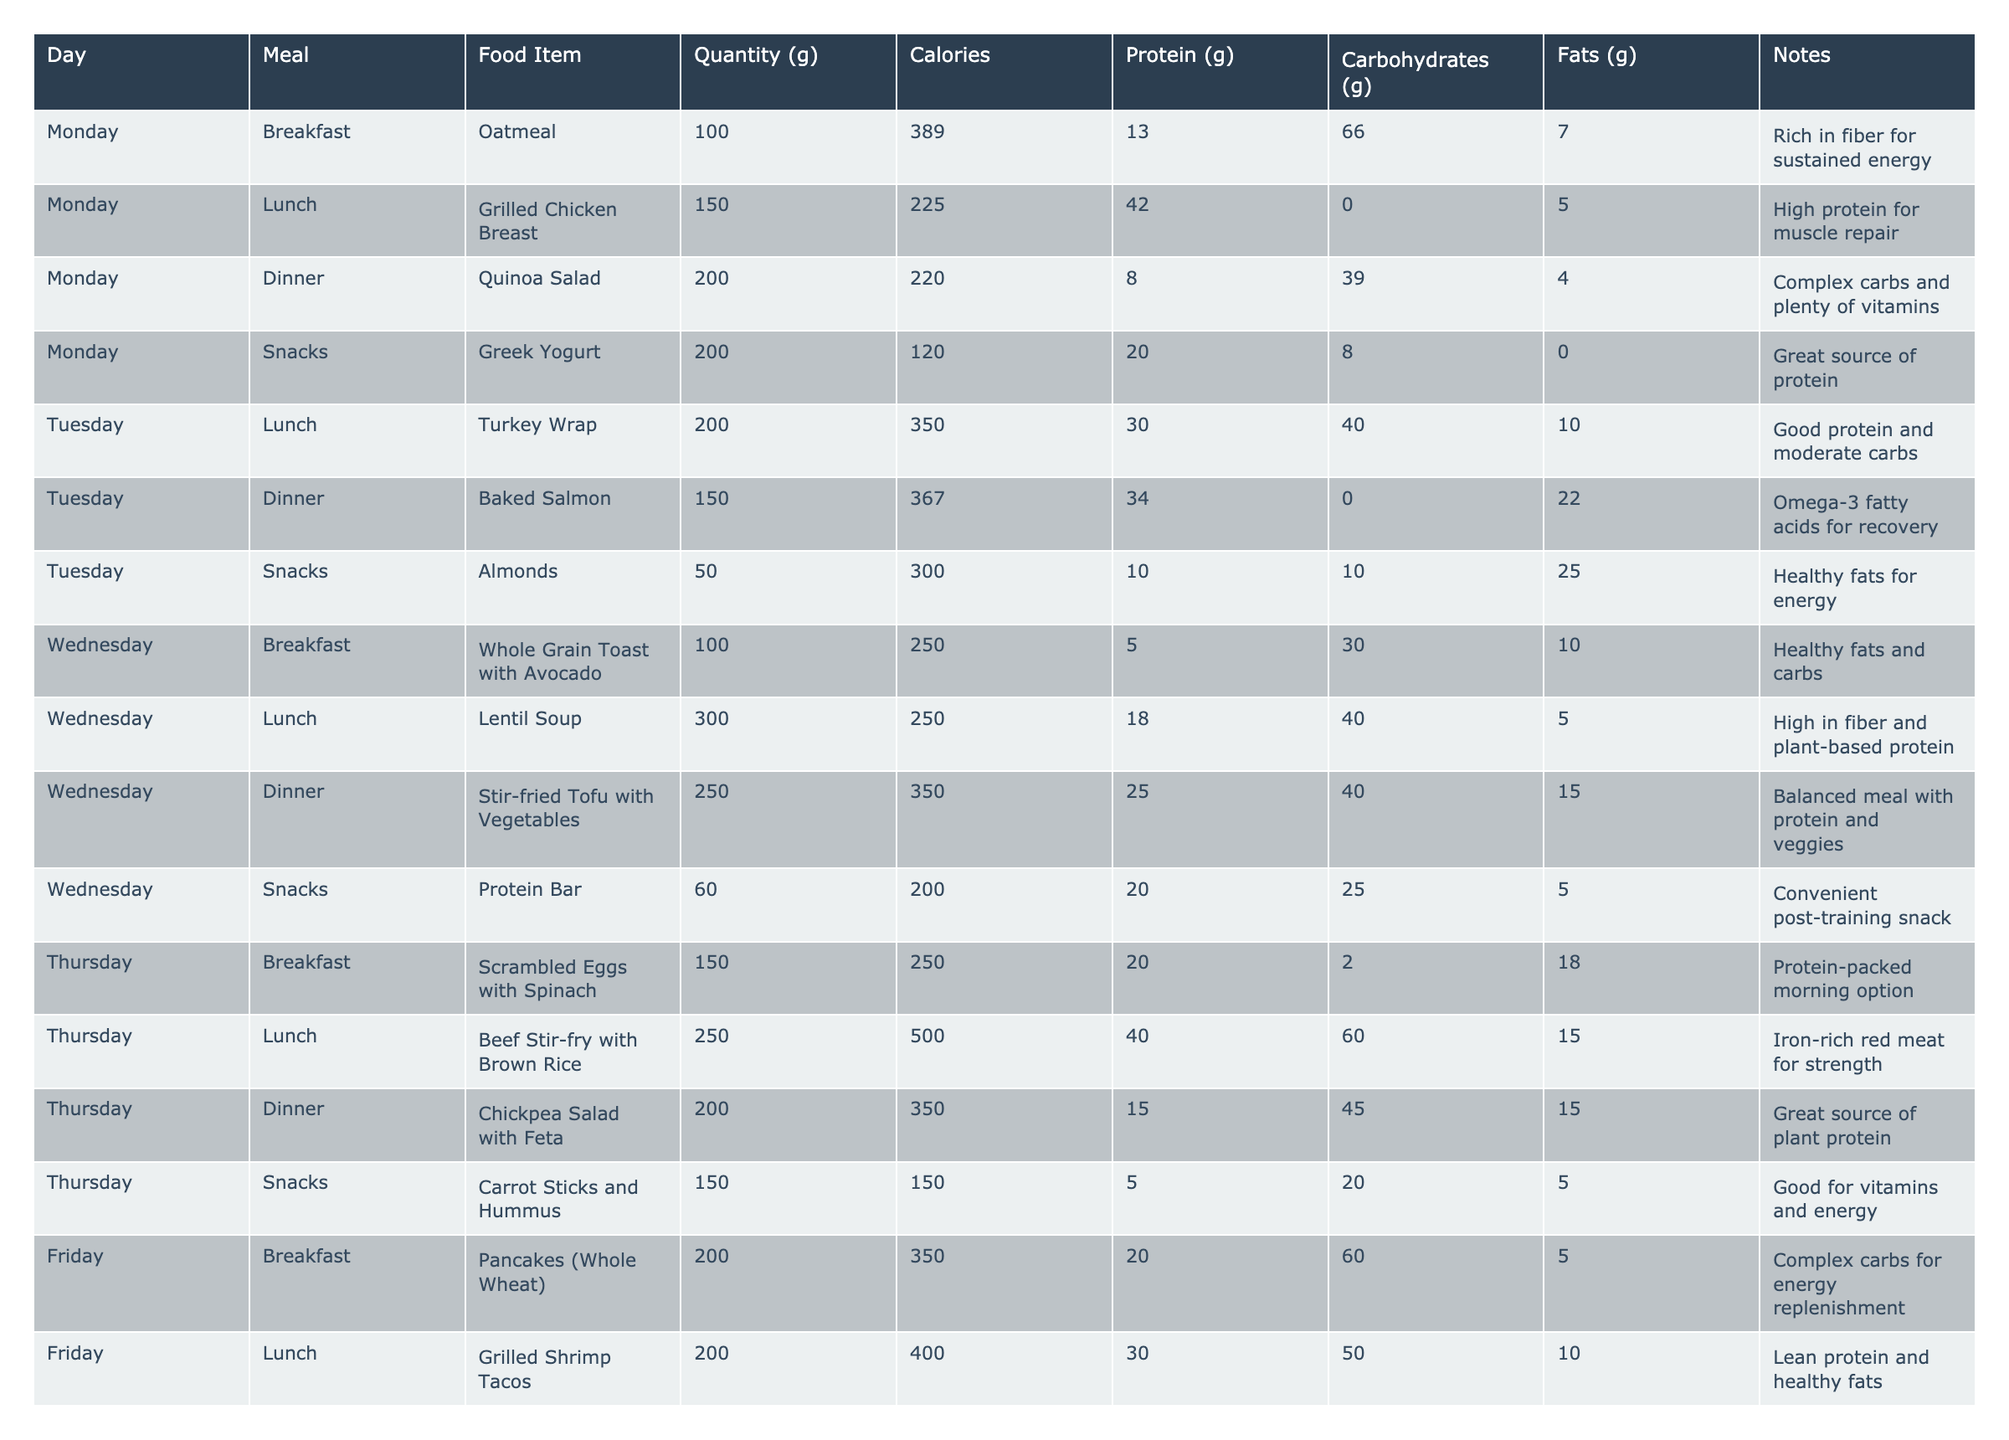What is the total calorie intake for Monday? On Monday, the calorie values for each meal are: Breakfast (389), Lunch (225), Dinner (220), and Snacks (120). Adding these together gives us 389 + 225 + 220 + 120 = 954.
Answer: 954 What food item has the highest protein content on Friday? On Friday, the food items and their protein contents are: Breakfast (20g), Lunch (30g), Dinner (25g), and Snacks (10g). The highest protein content is 30g from Grilled Shrimp Tacos.
Answer: Grilled Shrimp Tacos Which meal has the most carbohydrates on Wednesday? For Wednesday, the carbohydrate contents are: Breakfast (30g), Lunch (40g), Dinner (40g), and Snacks (25g). Both Lunch and Dinner have the highest at 40g each.
Answer: Lunch and Dinner Is the Baked Salmon considered high in protein? The protein content of Baked Salmon is 34g, which is a high amount for a single meal, indicating it is indeed high in protein.
Answer: Yes What is the average caloric intake across all dinners? The dinner calorie values are: 220, 367, 350, 350, 500, 500. Summing these gives 220 + 367 + 350 + 350 + 500 + 500 = 2287. There are 6 dinners, so the average is 2287 / 6 = approximately 381.17.
Answer: 381.17 On which day are the snacks high in healthy fats? Reviewing the snacks across the week, we find: Monday (0g), Tuesday (25g), Wednesday (5g), Thursday (5g), Friday (20g), Saturday (12g), and Sunday (15g). The highest fat content from snacks occurs on Tuesday at 25g.
Answer: Tuesday How many meals per day are labeled as high in protein? High protein meals include: Lunch on Monday (Grilled Chicken Breast), Tuesday (Turkey Wrap), Wednesday (Stir-fried Tofu with Vegetables), Thursday (Scrambled Eggs with Spinach), Friday (Grilled Shrimp Tacos), Saturday (Grilled Lamb with Sweet Potatoes), and Sunday (Grilled Chicken Salad). That totals to 7 high protein meals.
Answer: 7 Which meal on Saturday provides the most calories? On Saturday, the calorie values for each meal are: Breakfast (300), Lunch (450), Dinner (500), and Snacks (200). The Dinner provides the most calories at 500.
Answer: Dinner What was the total fat content for the snacks throughout the week? Summing the fat contents for the snacks: Monday (0g), Tuesday (25g), Wednesday (5g), Thursday (5g), Friday (20g), Saturday (12g), Sunday (15g) results in 0 + 25 + 5 + 5 + 20 + 12 + 15 = 82g of fat in total.
Answer: 82g Which day features the most varied sources of protein in meals? Analyzing the protein sources through the week, Saturday has multiple sources: a Fruit Smoothie Bowl (25g), a Quinoa and Black Bean Bowl (18g), Grilled Lamb (35g), and dark chocolate (2g), showcasing diverse protein sources.
Answer: Saturday 